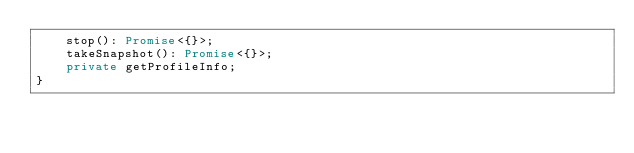<code> <loc_0><loc_0><loc_500><loc_500><_TypeScript_>    stop(): Promise<{}>;
    takeSnapshot(): Promise<{}>;
    private getProfileInfo;
}
</code> 